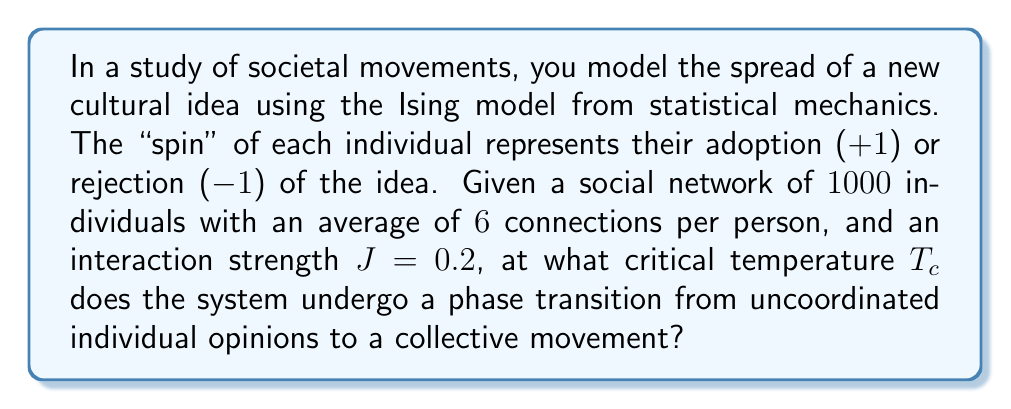Can you solve this math problem? To solve this problem, we'll use the mean-field approximation of the Ising model, which is suitable for analyzing phase transitions in complex systems like societal movements.

Step 1: Recall the critical temperature formula for the mean-field Ising model:
$$T_c = zJ$$
Where $z$ is the average number of connections per node, and $J$ is the interaction strength.

Step 2: Identify the given values:
- Average connections per person, $z = 6$
- Interaction strength, $J = 0.2$

Step 3: Substitute these values into the formula:
$$T_c = 6 \times 0.2$$

Step 4: Calculate the critical temperature:
$$T_c = 1.2$$

This critical temperature represents the point at which the system transitions from a disordered state (uncoordinated individual opinions) to an ordered state (collective movement). Below this temperature, the system tends to align in one direction, representing the formation of a cohesive societal movement. Above this temperature, thermal fluctuations dominate, and individuals' opinions remain largely independent.
Answer: $T_c = 1.2$ 